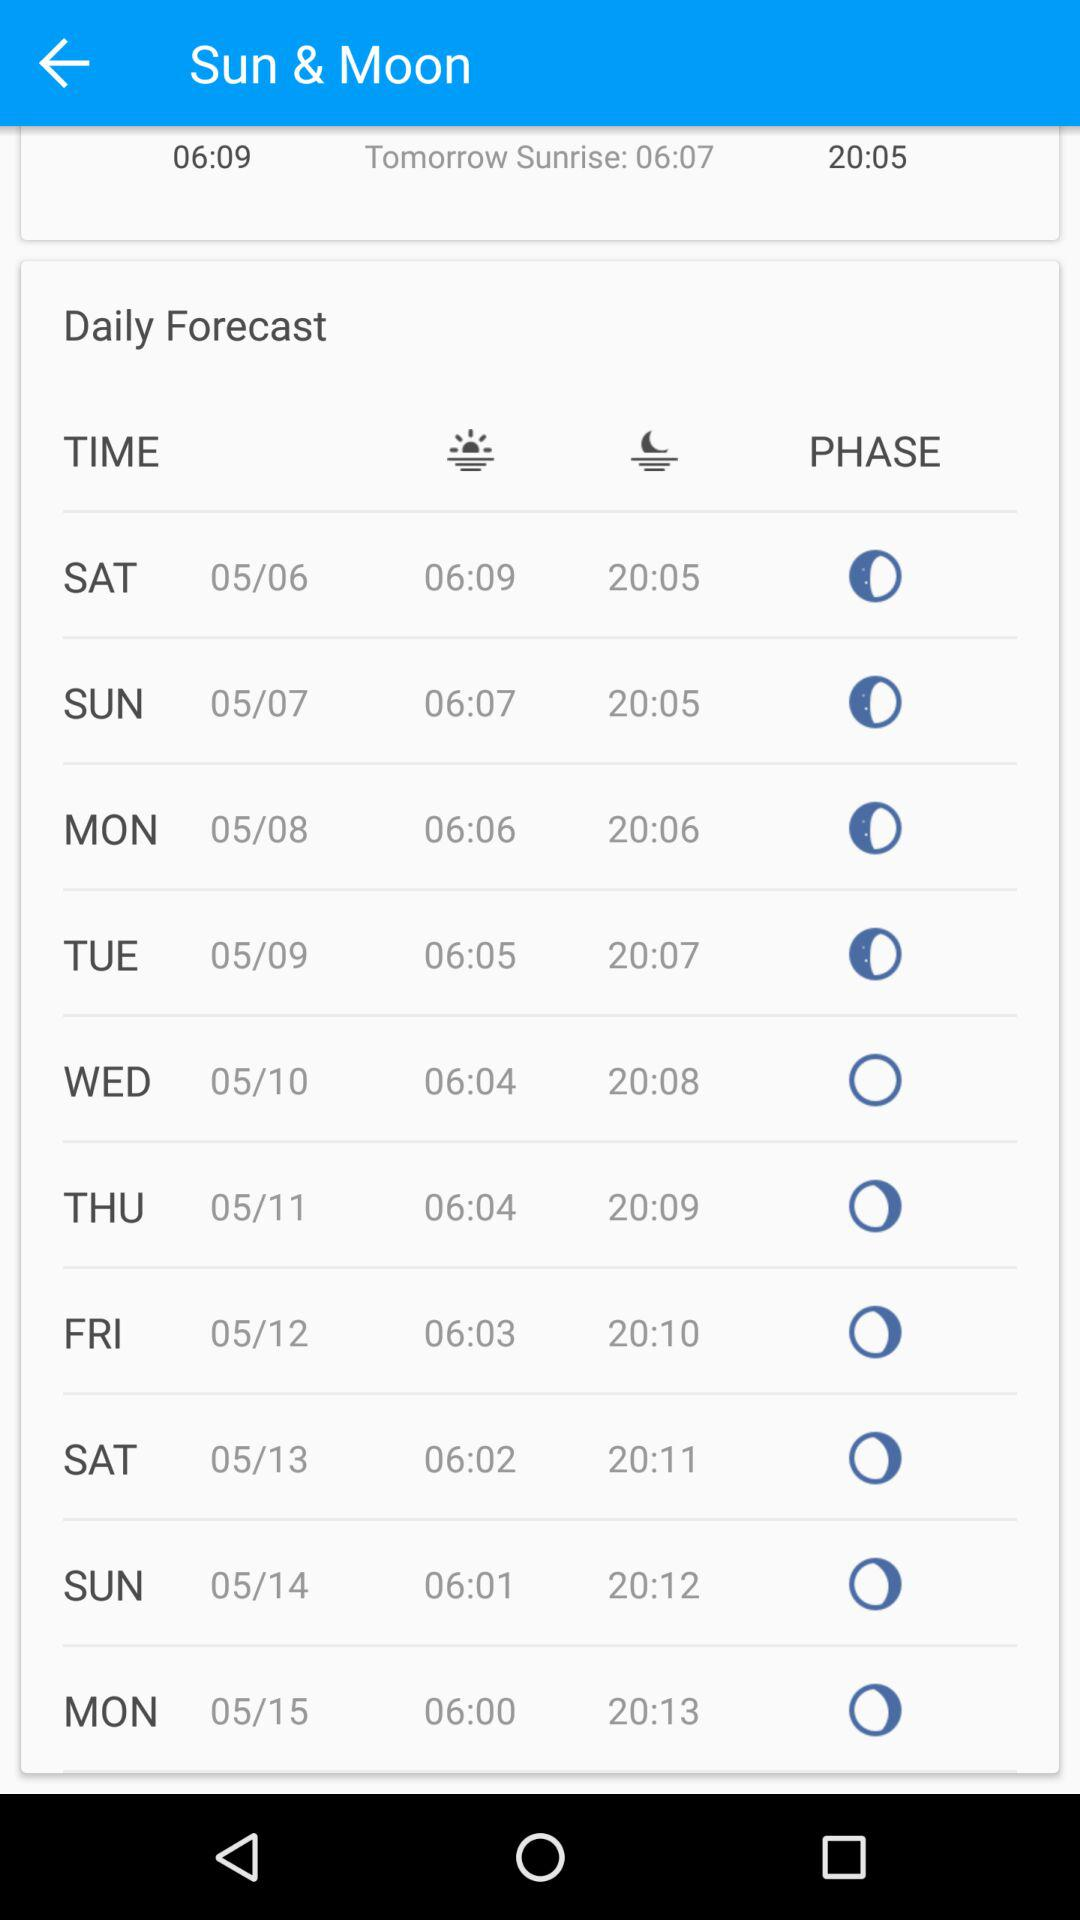What is the time of sunrise on Saturday, May 6th? The time of sunrise is 6:09. 